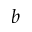Convert formula to latex. <formula><loc_0><loc_0><loc_500><loc_500>b</formula> 